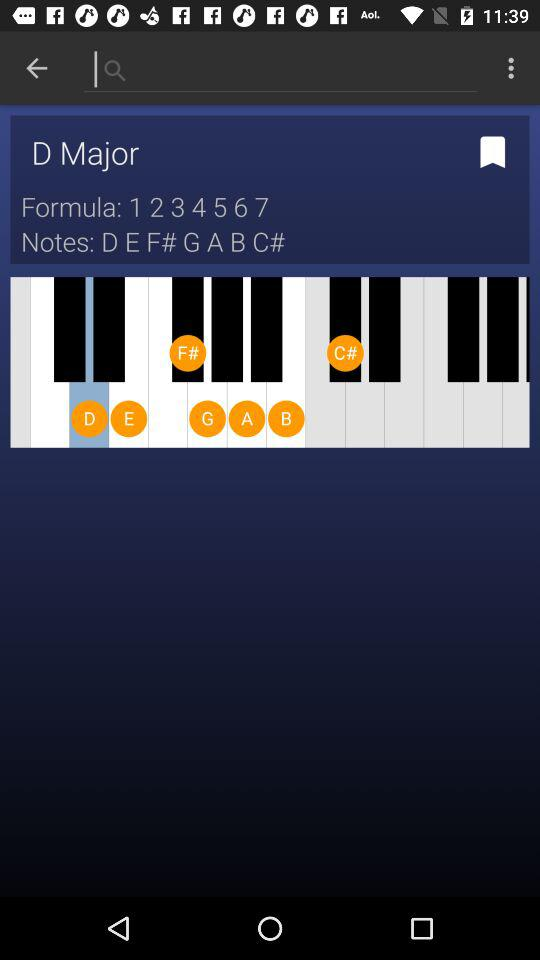What is the user name?
When the provided information is insufficient, respond with <no answer>. <no answer> 